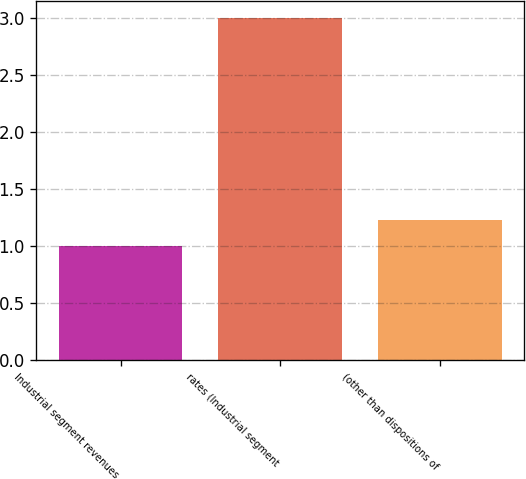Convert chart. <chart><loc_0><loc_0><loc_500><loc_500><bar_chart><fcel>Industrial segment revenues<fcel>rates (Industrial segment<fcel>(other than dispositions of<nl><fcel>1<fcel>3<fcel>1.23<nl></chart> 